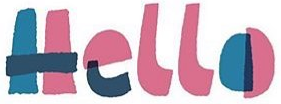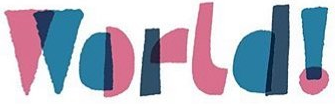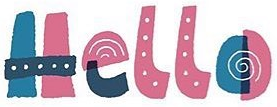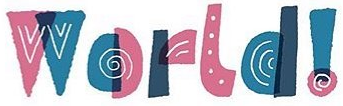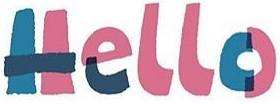What text is displayed in these images sequentially, separated by a semicolon? Hello; World!; Hello; World!; Hello 